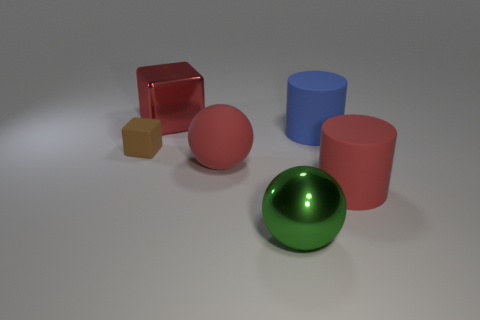Add 1 big blue rubber objects. How many objects exist? 7 Subtract all cubes. How many objects are left? 4 Add 5 large metallic balls. How many large metallic balls are left? 6 Add 4 red balls. How many red balls exist? 5 Subtract 0 green blocks. How many objects are left? 6 Subtract all small blue blocks. Subtract all large blue cylinders. How many objects are left? 5 